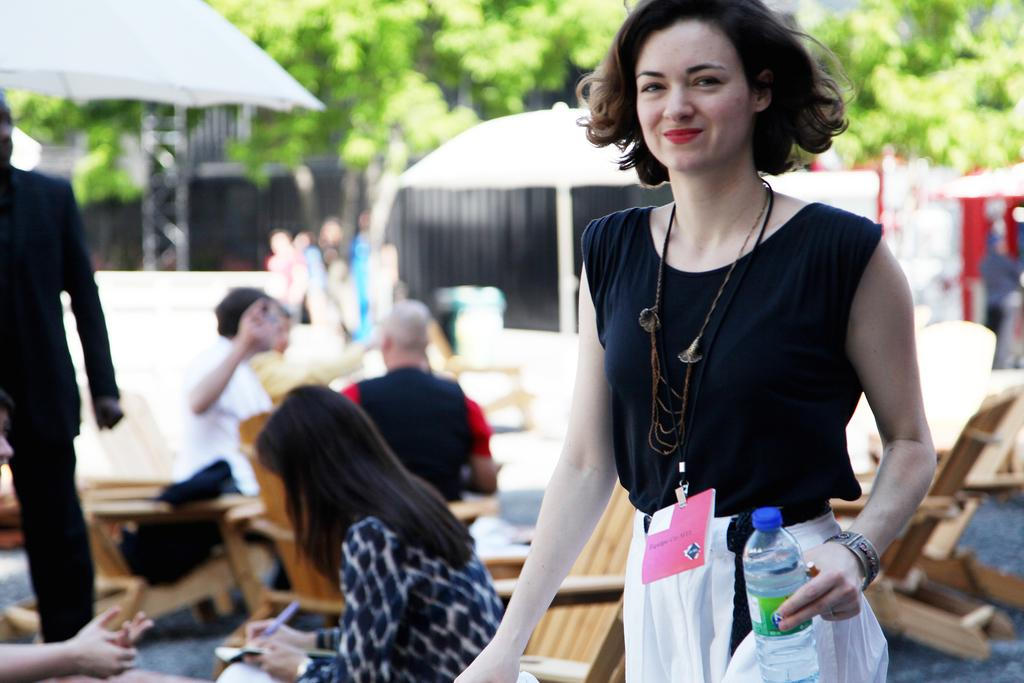Who is the main subject in the image? There is a woman in the image. What is the woman doing in the image? The woman is standing. What is the woman holding in her hand? The woman is holding a water bottle in her hand. What are the other people in the image doing? There are people seated on chairs in the image. What can be seen in the background of the image? There are trees visible in the background of the image. What type of grape is the woman eating in the image? There is no grape present in the image, and the woman is holding a water bottle, not a grape. Is the woman's mother also present in the image? The provided facts do not mention the presence of the woman's mother, so we cannot determine if she is present in the image. 